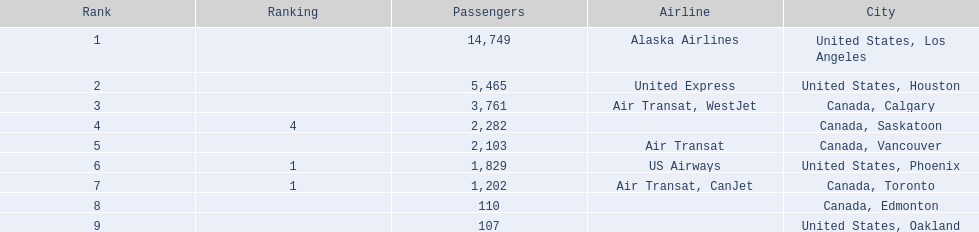What numbers are in the passengers column? 14,749, 5,465, 3,761, 2,282, 2,103, 1,829, 1,202, 110, 107. Which number is the lowest number in the passengers column? 107. What city is associated with this number? United States, Oakland. 